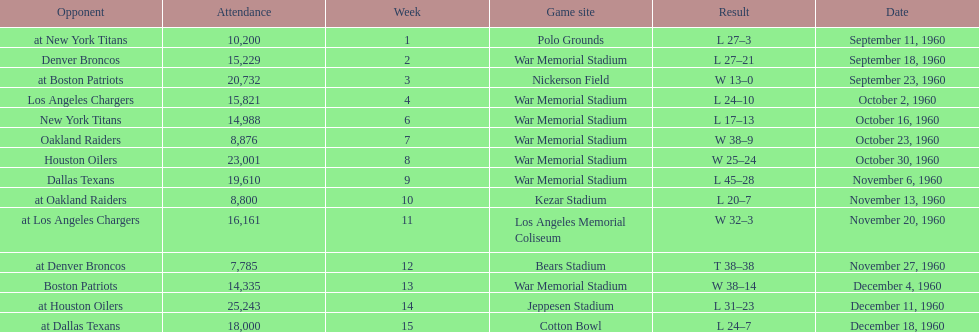How many times was war memorial stadium the game site? 6. 